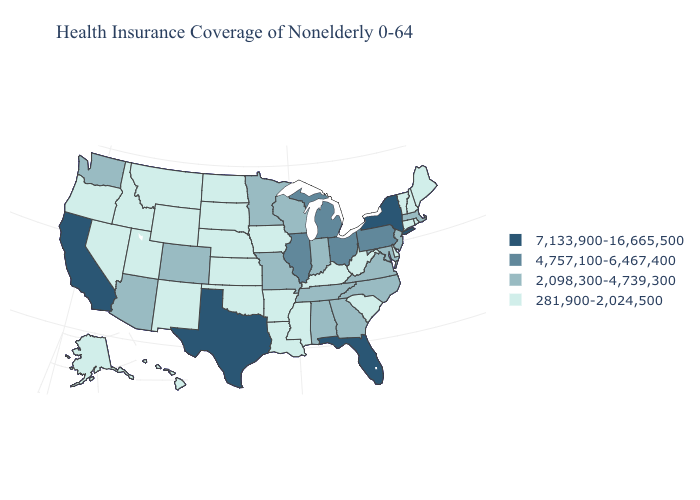Does New Hampshire have a lower value than Georgia?
Be succinct. Yes. What is the highest value in the Northeast ?
Give a very brief answer. 7,133,900-16,665,500. Name the states that have a value in the range 4,757,100-6,467,400?
Keep it brief. Illinois, Michigan, Ohio, Pennsylvania. How many symbols are there in the legend?
Quick response, please. 4. Name the states that have a value in the range 7,133,900-16,665,500?
Short answer required. California, Florida, New York, Texas. Which states have the lowest value in the USA?
Quick response, please. Alaska, Arkansas, Connecticut, Delaware, Hawaii, Idaho, Iowa, Kansas, Kentucky, Louisiana, Maine, Mississippi, Montana, Nebraska, Nevada, New Hampshire, New Mexico, North Dakota, Oklahoma, Oregon, Rhode Island, South Carolina, South Dakota, Utah, Vermont, West Virginia, Wyoming. Name the states that have a value in the range 2,098,300-4,739,300?
Be succinct. Alabama, Arizona, Colorado, Georgia, Indiana, Maryland, Massachusetts, Minnesota, Missouri, New Jersey, North Carolina, Tennessee, Virginia, Washington, Wisconsin. Is the legend a continuous bar?
Quick response, please. No. Among the states that border Rhode Island , which have the lowest value?
Answer briefly. Connecticut. Among the states that border New York , which have the lowest value?
Short answer required. Connecticut, Vermont. What is the lowest value in the MidWest?
Answer briefly. 281,900-2,024,500. What is the value of South Carolina?
Be succinct. 281,900-2,024,500. What is the highest value in the South ?
Give a very brief answer. 7,133,900-16,665,500. Does Ohio have the highest value in the MidWest?
Be succinct. Yes. Which states have the lowest value in the MidWest?
Be succinct. Iowa, Kansas, Nebraska, North Dakota, South Dakota. 